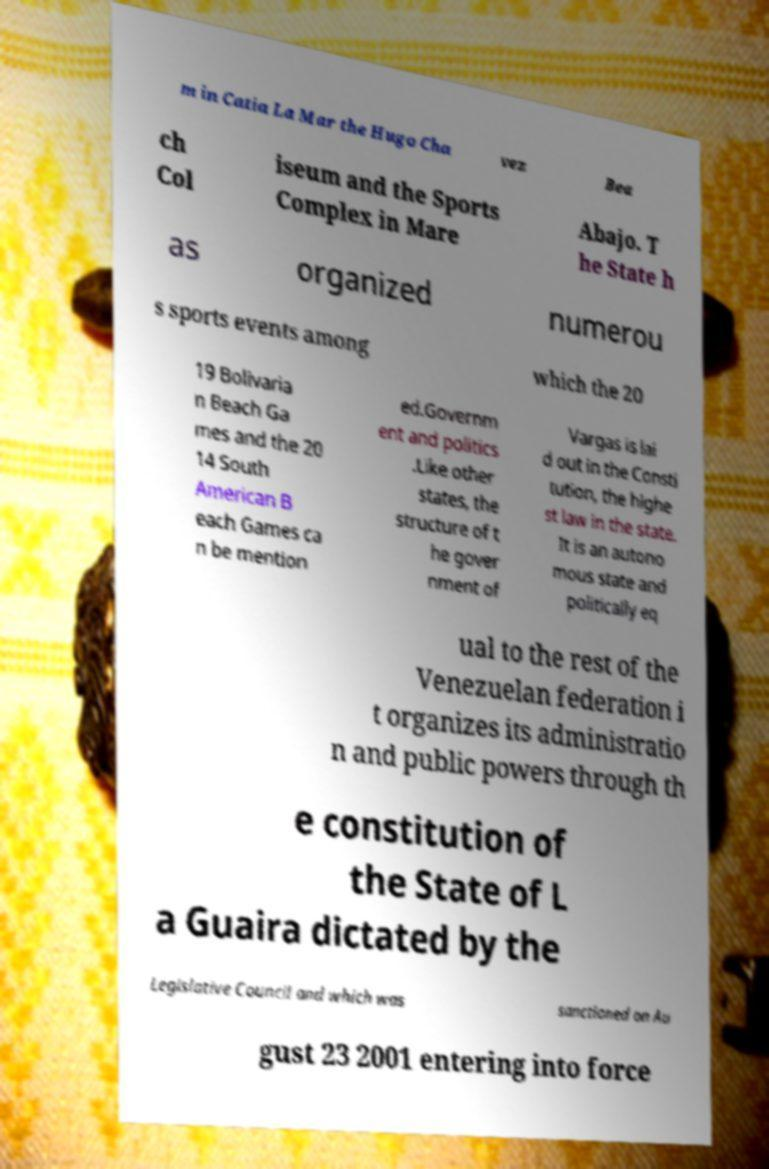Can you read and provide the text displayed in the image?This photo seems to have some interesting text. Can you extract and type it out for me? m in Catia La Mar the Hugo Cha vez Bea ch Col iseum and the Sports Complex in Mare Abajo. T he State h as organized numerou s sports events among which the 20 19 Bolivaria n Beach Ga mes and the 20 14 South American B each Games ca n be mention ed.Governm ent and politics .Like other states, the structure of t he gover nment of Vargas is lai d out in the Consti tution, the highe st law in the state. It is an autono mous state and politically eq ual to the rest of the Venezuelan federation i t organizes its administratio n and public powers through th e constitution of the State of L a Guaira dictated by the Legislative Council and which was sanctioned on Au gust 23 2001 entering into force 